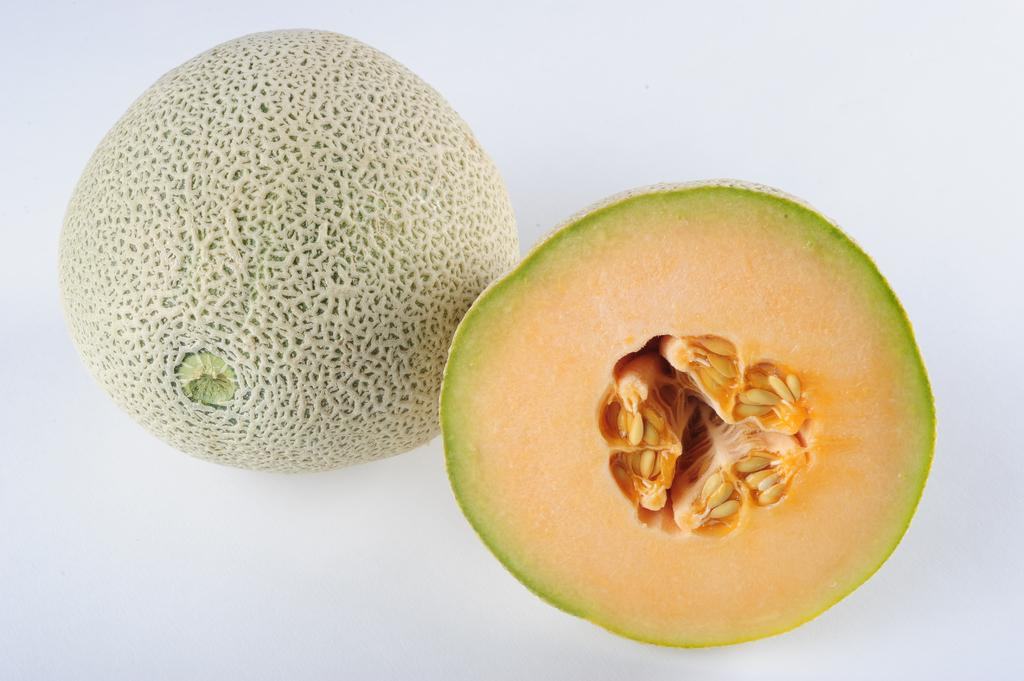What type of fruit is in the image? There is a muskmelon in the image. How is the muskmelon presented in the image? The muskmelon is cut into two pieces. What color is the background of the image? The background of the image is white. What hobbies does the potato enjoy in the image? There is no potato present in the image, and therefore no hobbies can be attributed to it. 